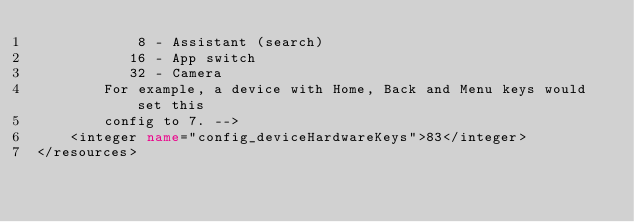<code> <loc_0><loc_0><loc_500><loc_500><_XML_>            8 - Assistant (search)
           16 - App switch
           32 - Camera
        For example, a device with Home, Back and Menu keys would set this
        config to 7. -->
    <integer name="config_deviceHardwareKeys">83</integer>
</resources></code> 